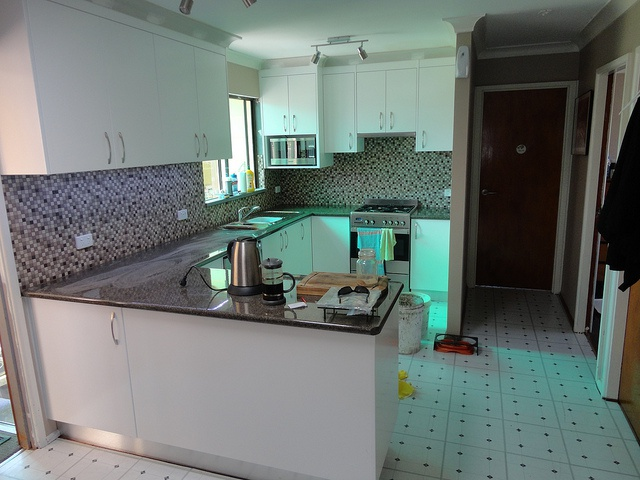Describe the objects in this image and their specific colors. I can see oven in gray, teal, and black tones, microwave in gray, teal, darkgray, and black tones, sink in gray and turquoise tones, bottle in gray, darkgray, and teal tones, and bottle in gray, olive, darkgray, lightgreen, and beige tones in this image. 